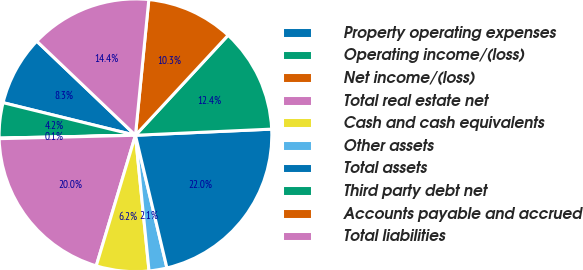Convert chart to OTSL. <chart><loc_0><loc_0><loc_500><loc_500><pie_chart><fcel>Property operating expenses<fcel>Operating income/(loss)<fcel>Net income/(loss)<fcel>Total real estate net<fcel>Cash and cash equivalents<fcel>Other assets<fcel>Total assets<fcel>Third party debt net<fcel>Accounts payable and accrued<fcel>Total liabilities<nl><fcel>8.28%<fcel>4.17%<fcel>0.07%<fcel>19.96%<fcel>6.23%<fcel>2.12%<fcel>22.01%<fcel>12.39%<fcel>10.33%<fcel>14.44%<nl></chart> 